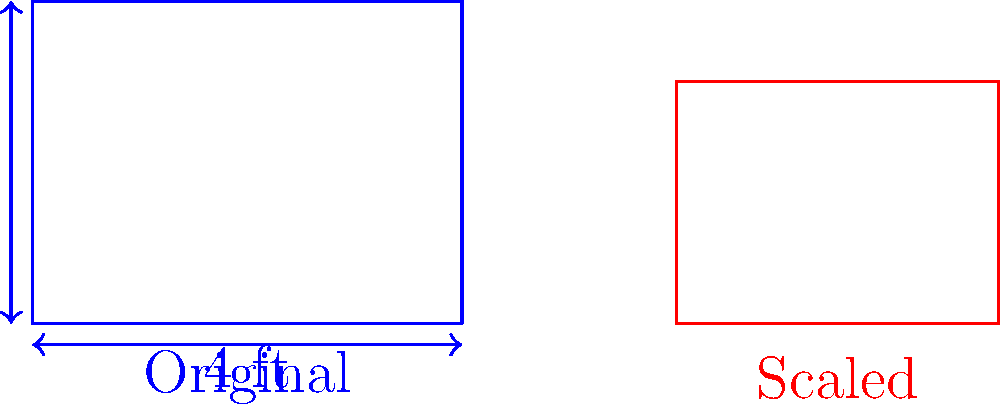You want to create a scaled-down version of an engine blueprint to fit in a display case. The original blueprint measures 4 feet wide by 3 feet tall. If the display case can accommodate a width of 3 feet, what will be the height of the scaled blueprint to maintain the original aspect ratio? To solve this problem, we need to follow these steps:

1) First, let's identify the scale factor for the width:
   New width / Original width = $3 \text{ ft} / 4 \text{ ft} = 0.75$

2) To maintain the aspect ratio, we need to use this same scale factor for the height:
   New height = Original height $\times$ Scale factor
   New height = $3 \text{ ft} \times 0.75$

3) Let's calculate:
   New height = $3 \text{ ft} \times 0.75 = 2.25 \text{ ft}$

Therefore, to maintain the original aspect ratio, the height of the scaled blueprint should be 2.25 feet when the width is scaled to 3 feet.

This scaling process is an example of uniform scaling, where all dimensions are multiplied by the same factor to preserve the shape of the original object.
Answer: 2.25 feet 